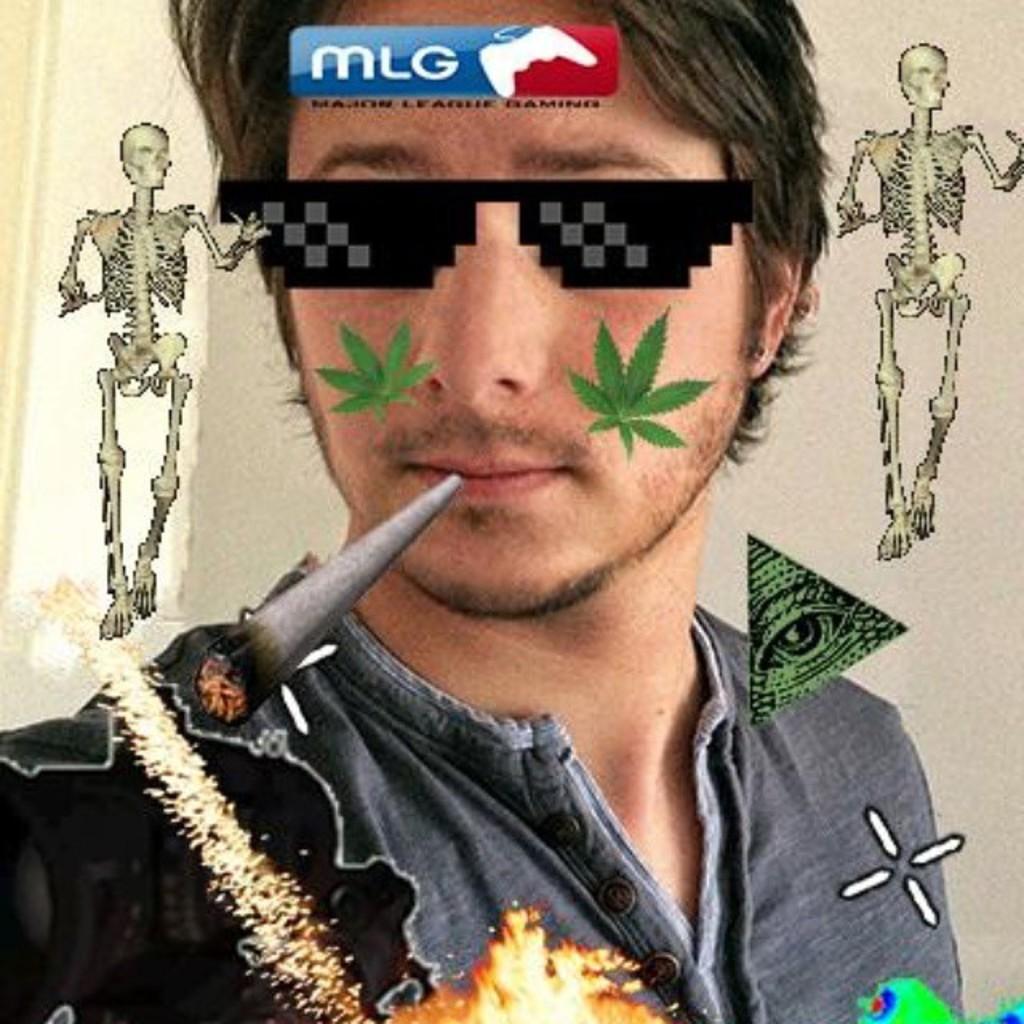Can you describe this image briefly? Here in this picture we can see a persons face and it is edited with cigarette, goggles, skeletons and leaves on him here and there. 